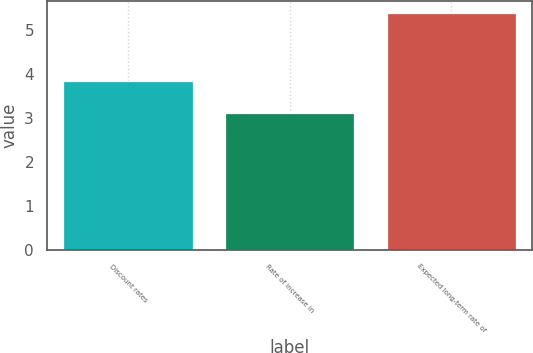<chart> <loc_0><loc_0><loc_500><loc_500><bar_chart><fcel>Discount rates<fcel>Rate of increase in<fcel>Expected long-term rate of<nl><fcel>3.85<fcel>3.11<fcel>5.39<nl></chart> 